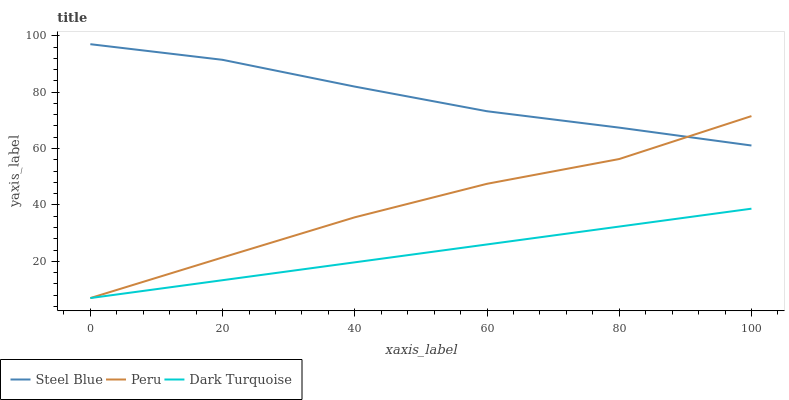Does Dark Turquoise have the minimum area under the curve?
Answer yes or no. Yes. Does Steel Blue have the maximum area under the curve?
Answer yes or no. Yes. Does Peru have the minimum area under the curve?
Answer yes or no. No. Does Peru have the maximum area under the curve?
Answer yes or no. No. Is Dark Turquoise the smoothest?
Answer yes or no. Yes. Is Peru the roughest?
Answer yes or no. Yes. Is Steel Blue the smoothest?
Answer yes or no. No. Is Steel Blue the roughest?
Answer yes or no. No. Does Steel Blue have the lowest value?
Answer yes or no. No. Does Steel Blue have the highest value?
Answer yes or no. Yes. Does Peru have the highest value?
Answer yes or no. No. Is Dark Turquoise less than Steel Blue?
Answer yes or no. Yes. Is Steel Blue greater than Dark Turquoise?
Answer yes or no. Yes. Does Peru intersect Dark Turquoise?
Answer yes or no. Yes. Is Peru less than Dark Turquoise?
Answer yes or no. No. Is Peru greater than Dark Turquoise?
Answer yes or no. No. Does Dark Turquoise intersect Steel Blue?
Answer yes or no. No. 